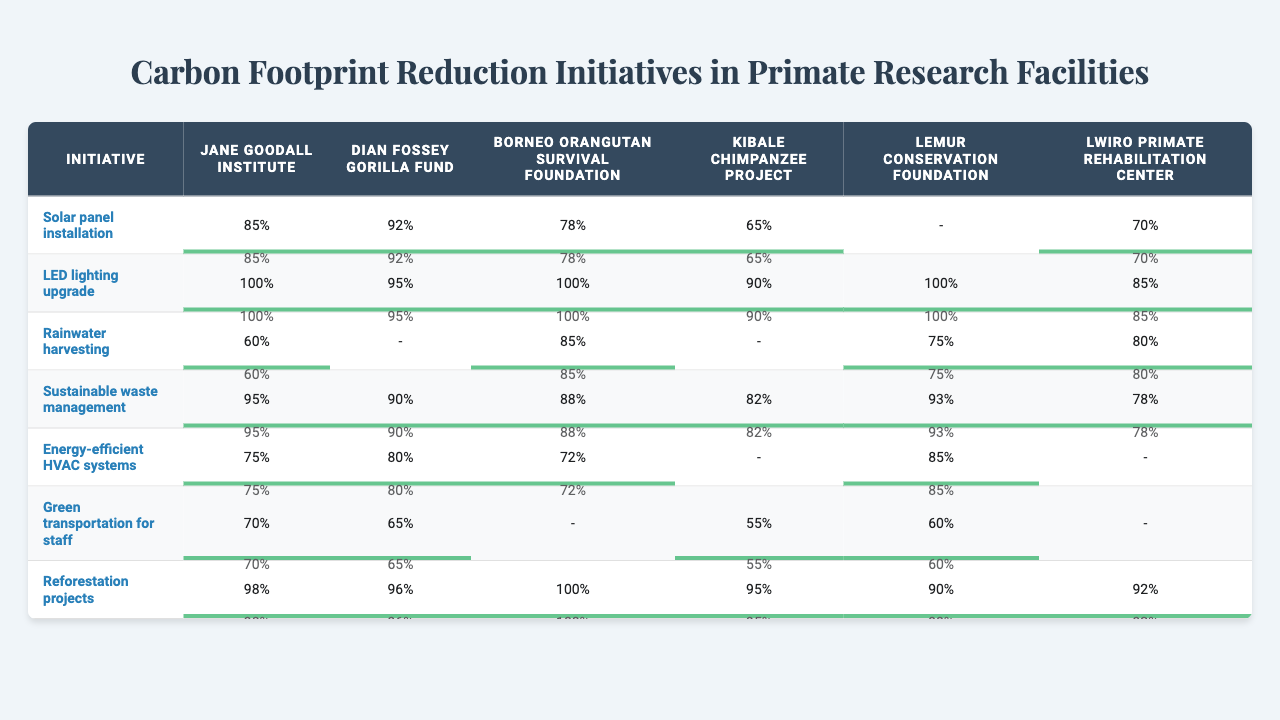What is the highest percentage for solar panel installation across the facilities? The highest percentage for solar panel installation is 92%, achieved by the Dian Fossey Gorilla Fund.
Answer: 92% Which facility has the lowest score in green transportation for staff? The Kibale Chimpanzee Project has the lowest score in green transportation for staff, with a score of 55%.
Answer: 55% What is the average percentage for sustainable waste management across all facilities? The percentages for sustainable waste management are 95, 90, 88, 82, 93, and 78. The sum is 526, and with 6 data points, the average is 526/6 = 87.67.
Answer: 87.67 Which facility shows the highest percentage in reforestation projects? The Borneo Orangutan Survival Foundation demonstrates the highest percentage in reforestation projects with a score of 100%.
Answer: 100% Is there any facility that has a percentage of 100% for LED lighting upgrades? Yes, the Jane Goodall Institute, Borneo Orangutan Survival Foundation, and Lemur Conservation Foundation each have a percentage of 100% for LED lighting upgrades.
Answer: Yes What percentage does the Dian Fossey Gorilla Fund achieve in rainwater harvesting? The Dian Fossey Gorilla Fund does not have a recorded percentage for rainwater harvesting, thus it is not displayed in the table.
Answer: - Which initiative has consistently high scores across all facilities? The initiative with consistently high scores is "LED lighting upgrade," with scores ranging from 85% to 100% across all involved facilities.
Answer: LED lighting upgrade What is the percentage difference in sustainable waste management between the highest (Jane Goodall Institute) and the lowest (Lwiro Primate Rehabilitation Center)? The highest percentage for sustainable waste management is 95% (Jane Goodall Institute) and the lowest is 78% (Lwiro Primate Rehabilitation Center). The difference is 95 - 78 = 17%.
Answer: 17% In which initiatives does the Lemur Conservation Foundation show a score of 90% or higher? The Lemur Conservation Foundation has scores of 100% for LED lighting upgrade and 93% for sustainable waste management, as well as 90% for reforestation projects.
Answer: LED lighting upgrade, sustainable waste management, reforestation projects What is the overall initiative with the lowest average score across all facilities? The overall initiative with the lowest average score across all facilities is "Green transportation for staff," with scores of 70, 65, 55, and 60. The sum is 250, and the average is 250/4 = 62.5.
Answer: 62.5 